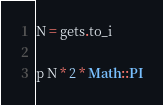Convert code to text. <code><loc_0><loc_0><loc_500><loc_500><_Ruby_>N = gets.to_i

p N * 2 * Math::PI</code> 